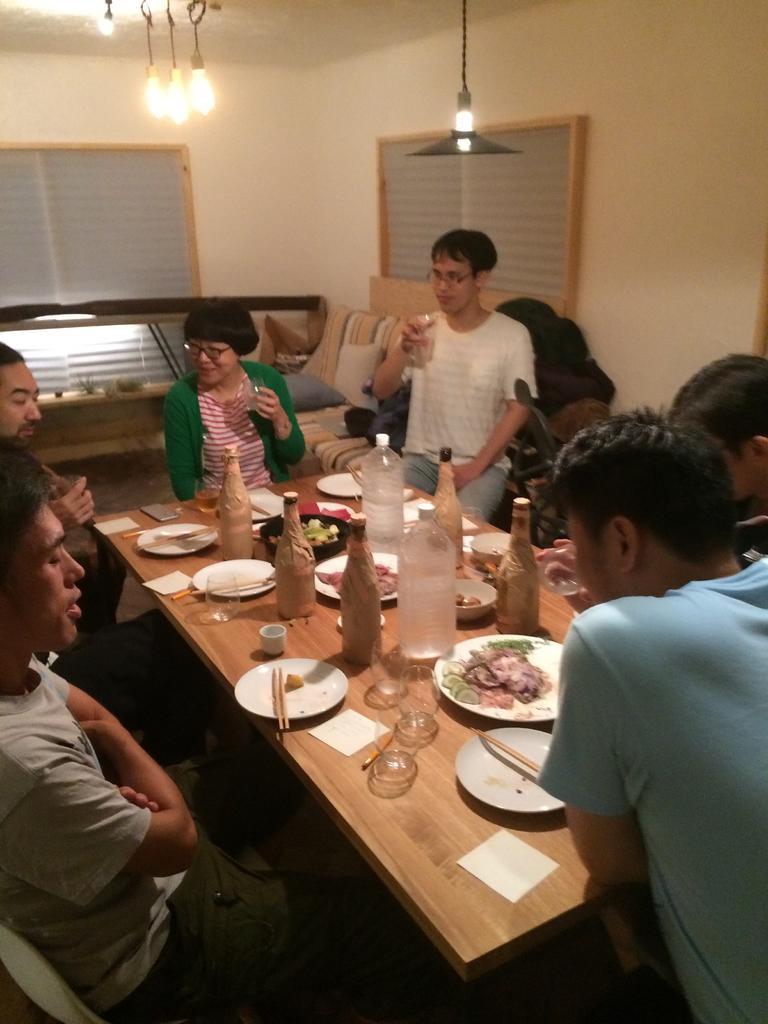Please provide a concise description of this image. This image is taken in a room few persons are sitting around the table. On the table there are bottles, plates having food, glasses, sticks, cups. At the middle of the image there is a sofa having two cushions on it. Few lights hanged from the roof. 